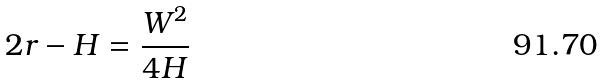Convert formula to latex. <formula><loc_0><loc_0><loc_500><loc_500>2 r - H = \frac { W ^ { 2 } } { 4 H }</formula> 